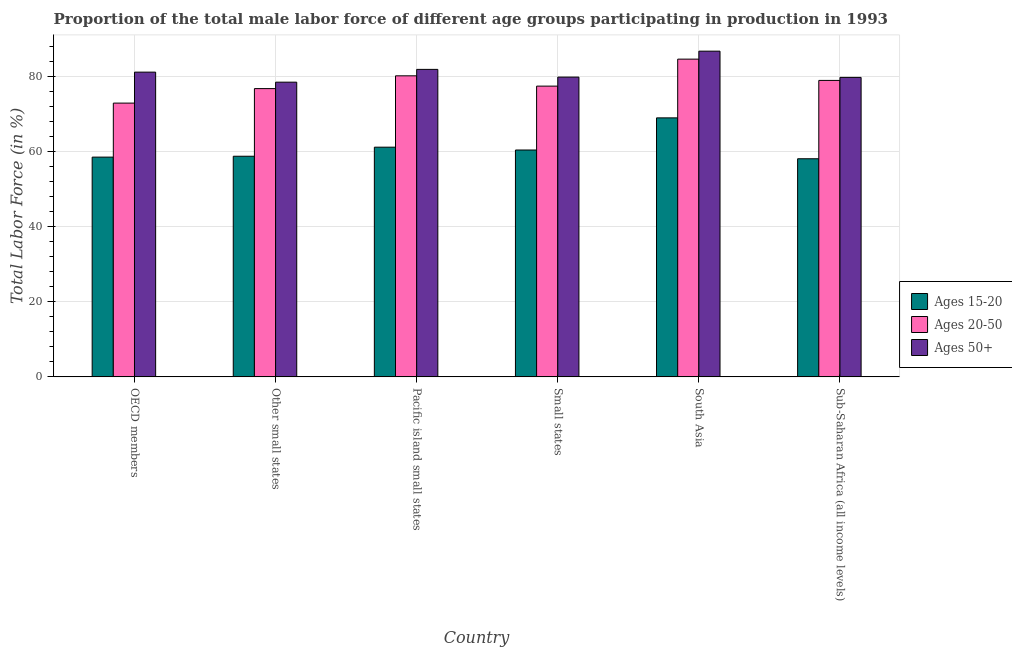How many different coloured bars are there?
Keep it short and to the point. 3. How many groups of bars are there?
Make the answer very short. 6. What is the label of the 2nd group of bars from the left?
Your answer should be very brief. Other small states. In how many cases, is the number of bars for a given country not equal to the number of legend labels?
Provide a short and direct response. 0. What is the percentage of male labor force within the age group 20-50 in Pacific island small states?
Offer a very short reply. 80.16. Across all countries, what is the maximum percentage of male labor force within the age group 15-20?
Make the answer very short. 68.96. Across all countries, what is the minimum percentage of male labor force above age 50?
Ensure brevity in your answer.  78.47. In which country was the percentage of male labor force within the age group 20-50 minimum?
Give a very brief answer. OECD members. What is the total percentage of male labor force above age 50 in the graph?
Provide a short and direct response. 487.77. What is the difference between the percentage of male labor force within the age group 20-50 in OECD members and that in Sub-Saharan Africa (all income levels)?
Give a very brief answer. -6.04. What is the difference between the percentage of male labor force within the age group 15-20 in South Asia and the percentage of male labor force above age 50 in Other small states?
Your response must be concise. -9.51. What is the average percentage of male labor force within the age group 15-20 per country?
Your response must be concise. 60.98. What is the difference between the percentage of male labor force within the age group 15-20 and percentage of male labor force within the age group 20-50 in Other small states?
Your answer should be very brief. -18.01. What is the ratio of the percentage of male labor force within the age group 20-50 in OECD members to that in Small states?
Make the answer very short. 0.94. What is the difference between the highest and the second highest percentage of male labor force within the age group 15-20?
Give a very brief answer. 7.8. What is the difference between the highest and the lowest percentage of male labor force within the age group 20-50?
Offer a terse response. 11.71. Is the sum of the percentage of male labor force within the age group 20-50 in OECD members and Small states greater than the maximum percentage of male labor force above age 50 across all countries?
Offer a very short reply. Yes. What does the 2nd bar from the left in OECD members represents?
Keep it short and to the point. Ages 20-50. What does the 3rd bar from the right in South Asia represents?
Make the answer very short. Ages 15-20. Is it the case that in every country, the sum of the percentage of male labor force within the age group 15-20 and percentage of male labor force within the age group 20-50 is greater than the percentage of male labor force above age 50?
Offer a very short reply. Yes. Does the graph contain grids?
Provide a succinct answer. Yes. Where does the legend appear in the graph?
Give a very brief answer. Center right. How are the legend labels stacked?
Provide a short and direct response. Vertical. What is the title of the graph?
Offer a very short reply. Proportion of the total male labor force of different age groups participating in production in 1993. What is the label or title of the X-axis?
Give a very brief answer. Country. What is the label or title of the Y-axis?
Offer a terse response. Total Labor Force (in %). What is the Total Labor Force (in %) in Ages 15-20 in OECD members?
Provide a short and direct response. 58.51. What is the Total Labor Force (in %) in Ages 20-50 in OECD members?
Your response must be concise. 72.9. What is the Total Labor Force (in %) of Ages 50+ in OECD members?
Make the answer very short. 81.14. What is the Total Labor Force (in %) in Ages 15-20 in Other small states?
Offer a very short reply. 58.75. What is the Total Labor Force (in %) in Ages 20-50 in Other small states?
Provide a short and direct response. 76.76. What is the Total Labor Force (in %) in Ages 50+ in Other small states?
Ensure brevity in your answer.  78.47. What is the Total Labor Force (in %) in Ages 15-20 in Pacific island small states?
Your answer should be very brief. 61.16. What is the Total Labor Force (in %) in Ages 20-50 in Pacific island small states?
Provide a succinct answer. 80.16. What is the Total Labor Force (in %) of Ages 50+ in Pacific island small states?
Your answer should be very brief. 81.87. What is the Total Labor Force (in %) of Ages 15-20 in Small states?
Provide a succinct answer. 60.41. What is the Total Labor Force (in %) of Ages 20-50 in Small states?
Keep it short and to the point. 77.42. What is the Total Labor Force (in %) of Ages 50+ in Small states?
Offer a terse response. 79.82. What is the Total Labor Force (in %) in Ages 15-20 in South Asia?
Give a very brief answer. 68.96. What is the Total Labor Force (in %) of Ages 20-50 in South Asia?
Your answer should be compact. 84.6. What is the Total Labor Force (in %) of Ages 50+ in South Asia?
Ensure brevity in your answer.  86.73. What is the Total Labor Force (in %) of Ages 15-20 in Sub-Saharan Africa (all income levels)?
Your response must be concise. 58.08. What is the Total Labor Force (in %) in Ages 20-50 in Sub-Saharan Africa (all income levels)?
Your response must be concise. 78.94. What is the Total Labor Force (in %) of Ages 50+ in Sub-Saharan Africa (all income levels)?
Your answer should be compact. 79.74. Across all countries, what is the maximum Total Labor Force (in %) in Ages 15-20?
Provide a succinct answer. 68.96. Across all countries, what is the maximum Total Labor Force (in %) of Ages 20-50?
Your answer should be very brief. 84.6. Across all countries, what is the maximum Total Labor Force (in %) of Ages 50+?
Your answer should be very brief. 86.73. Across all countries, what is the minimum Total Labor Force (in %) of Ages 15-20?
Provide a short and direct response. 58.08. Across all countries, what is the minimum Total Labor Force (in %) in Ages 20-50?
Your answer should be very brief. 72.9. Across all countries, what is the minimum Total Labor Force (in %) in Ages 50+?
Make the answer very short. 78.47. What is the total Total Labor Force (in %) of Ages 15-20 in the graph?
Give a very brief answer. 365.87. What is the total Total Labor Force (in %) of Ages 20-50 in the graph?
Provide a succinct answer. 470.78. What is the total Total Labor Force (in %) in Ages 50+ in the graph?
Provide a succinct answer. 487.77. What is the difference between the Total Labor Force (in %) in Ages 15-20 in OECD members and that in Other small states?
Provide a short and direct response. -0.23. What is the difference between the Total Labor Force (in %) in Ages 20-50 in OECD members and that in Other small states?
Your response must be concise. -3.86. What is the difference between the Total Labor Force (in %) in Ages 50+ in OECD members and that in Other small states?
Provide a short and direct response. 2.67. What is the difference between the Total Labor Force (in %) of Ages 15-20 in OECD members and that in Pacific island small states?
Ensure brevity in your answer.  -2.65. What is the difference between the Total Labor Force (in %) in Ages 20-50 in OECD members and that in Pacific island small states?
Provide a short and direct response. -7.26. What is the difference between the Total Labor Force (in %) of Ages 50+ in OECD members and that in Pacific island small states?
Offer a terse response. -0.73. What is the difference between the Total Labor Force (in %) in Ages 15-20 in OECD members and that in Small states?
Your answer should be compact. -1.9. What is the difference between the Total Labor Force (in %) of Ages 20-50 in OECD members and that in Small states?
Keep it short and to the point. -4.52. What is the difference between the Total Labor Force (in %) in Ages 50+ in OECD members and that in Small states?
Your answer should be very brief. 1.32. What is the difference between the Total Labor Force (in %) in Ages 15-20 in OECD members and that in South Asia?
Provide a short and direct response. -10.45. What is the difference between the Total Labor Force (in %) of Ages 20-50 in OECD members and that in South Asia?
Offer a terse response. -11.71. What is the difference between the Total Labor Force (in %) in Ages 50+ in OECD members and that in South Asia?
Give a very brief answer. -5.59. What is the difference between the Total Labor Force (in %) of Ages 15-20 in OECD members and that in Sub-Saharan Africa (all income levels)?
Keep it short and to the point. 0.44. What is the difference between the Total Labor Force (in %) in Ages 20-50 in OECD members and that in Sub-Saharan Africa (all income levels)?
Give a very brief answer. -6.04. What is the difference between the Total Labor Force (in %) of Ages 50+ in OECD members and that in Sub-Saharan Africa (all income levels)?
Your answer should be compact. 1.4. What is the difference between the Total Labor Force (in %) of Ages 15-20 in Other small states and that in Pacific island small states?
Offer a terse response. -2.42. What is the difference between the Total Labor Force (in %) in Ages 20-50 in Other small states and that in Pacific island small states?
Ensure brevity in your answer.  -3.4. What is the difference between the Total Labor Force (in %) in Ages 50+ in Other small states and that in Pacific island small states?
Your response must be concise. -3.4. What is the difference between the Total Labor Force (in %) in Ages 15-20 in Other small states and that in Small states?
Keep it short and to the point. -1.66. What is the difference between the Total Labor Force (in %) in Ages 20-50 in Other small states and that in Small states?
Make the answer very short. -0.66. What is the difference between the Total Labor Force (in %) of Ages 50+ in Other small states and that in Small states?
Provide a succinct answer. -1.35. What is the difference between the Total Labor Force (in %) of Ages 15-20 in Other small states and that in South Asia?
Make the answer very short. -10.22. What is the difference between the Total Labor Force (in %) in Ages 20-50 in Other small states and that in South Asia?
Give a very brief answer. -7.84. What is the difference between the Total Labor Force (in %) of Ages 50+ in Other small states and that in South Asia?
Your answer should be very brief. -8.26. What is the difference between the Total Labor Force (in %) of Ages 15-20 in Other small states and that in Sub-Saharan Africa (all income levels)?
Offer a very short reply. 0.67. What is the difference between the Total Labor Force (in %) of Ages 20-50 in Other small states and that in Sub-Saharan Africa (all income levels)?
Provide a succinct answer. -2.18. What is the difference between the Total Labor Force (in %) of Ages 50+ in Other small states and that in Sub-Saharan Africa (all income levels)?
Offer a very short reply. -1.27. What is the difference between the Total Labor Force (in %) of Ages 15-20 in Pacific island small states and that in Small states?
Provide a succinct answer. 0.75. What is the difference between the Total Labor Force (in %) of Ages 20-50 in Pacific island small states and that in Small states?
Ensure brevity in your answer.  2.74. What is the difference between the Total Labor Force (in %) of Ages 50+ in Pacific island small states and that in Small states?
Ensure brevity in your answer.  2.05. What is the difference between the Total Labor Force (in %) of Ages 15-20 in Pacific island small states and that in South Asia?
Your answer should be very brief. -7.8. What is the difference between the Total Labor Force (in %) of Ages 20-50 in Pacific island small states and that in South Asia?
Your answer should be very brief. -4.44. What is the difference between the Total Labor Force (in %) in Ages 50+ in Pacific island small states and that in South Asia?
Keep it short and to the point. -4.85. What is the difference between the Total Labor Force (in %) in Ages 15-20 in Pacific island small states and that in Sub-Saharan Africa (all income levels)?
Offer a terse response. 3.08. What is the difference between the Total Labor Force (in %) of Ages 20-50 in Pacific island small states and that in Sub-Saharan Africa (all income levels)?
Your answer should be compact. 1.22. What is the difference between the Total Labor Force (in %) in Ages 50+ in Pacific island small states and that in Sub-Saharan Africa (all income levels)?
Your response must be concise. 2.13. What is the difference between the Total Labor Force (in %) in Ages 15-20 in Small states and that in South Asia?
Offer a very short reply. -8.55. What is the difference between the Total Labor Force (in %) of Ages 20-50 in Small states and that in South Asia?
Your response must be concise. -7.19. What is the difference between the Total Labor Force (in %) in Ages 50+ in Small states and that in South Asia?
Your response must be concise. -6.91. What is the difference between the Total Labor Force (in %) of Ages 15-20 in Small states and that in Sub-Saharan Africa (all income levels)?
Your response must be concise. 2.33. What is the difference between the Total Labor Force (in %) of Ages 20-50 in Small states and that in Sub-Saharan Africa (all income levels)?
Provide a short and direct response. -1.52. What is the difference between the Total Labor Force (in %) of Ages 50+ in Small states and that in Sub-Saharan Africa (all income levels)?
Offer a terse response. 0.08. What is the difference between the Total Labor Force (in %) in Ages 15-20 in South Asia and that in Sub-Saharan Africa (all income levels)?
Ensure brevity in your answer.  10.89. What is the difference between the Total Labor Force (in %) of Ages 20-50 in South Asia and that in Sub-Saharan Africa (all income levels)?
Offer a terse response. 5.67. What is the difference between the Total Labor Force (in %) of Ages 50+ in South Asia and that in Sub-Saharan Africa (all income levels)?
Your answer should be very brief. 6.99. What is the difference between the Total Labor Force (in %) in Ages 15-20 in OECD members and the Total Labor Force (in %) in Ages 20-50 in Other small states?
Ensure brevity in your answer.  -18.25. What is the difference between the Total Labor Force (in %) of Ages 15-20 in OECD members and the Total Labor Force (in %) of Ages 50+ in Other small states?
Your answer should be compact. -19.96. What is the difference between the Total Labor Force (in %) of Ages 20-50 in OECD members and the Total Labor Force (in %) of Ages 50+ in Other small states?
Provide a short and direct response. -5.57. What is the difference between the Total Labor Force (in %) in Ages 15-20 in OECD members and the Total Labor Force (in %) in Ages 20-50 in Pacific island small states?
Ensure brevity in your answer.  -21.65. What is the difference between the Total Labor Force (in %) of Ages 15-20 in OECD members and the Total Labor Force (in %) of Ages 50+ in Pacific island small states?
Provide a short and direct response. -23.36. What is the difference between the Total Labor Force (in %) in Ages 20-50 in OECD members and the Total Labor Force (in %) in Ages 50+ in Pacific island small states?
Keep it short and to the point. -8.98. What is the difference between the Total Labor Force (in %) in Ages 15-20 in OECD members and the Total Labor Force (in %) in Ages 20-50 in Small states?
Ensure brevity in your answer.  -18.9. What is the difference between the Total Labor Force (in %) of Ages 15-20 in OECD members and the Total Labor Force (in %) of Ages 50+ in Small states?
Make the answer very short. -21.31. What is the difference between the Total Labor Force (in %) of Ages 20-50 in OECD members and the Total Labor Force (in %) of Ages 50+ in Small states?
Your answer should be compact. -6.92. What is the difference between the Total Labor Force (in %) in Ages 15-20 in OECD members and the Total Labor Force (in %) in Ages 20-50 in South Asia?
Offer a very short reply. -26.09. What is the difference between the Total Labor Force (in %) of Ages 15-20 in OECD members and the Total Labor Force (in %) of Ages 50+ in South Asia?
Keep it short and to the point. -28.21. What is the difference between the Total Labor Force (in %) of Ages 20-50 in OECD members and the Total Labor Force (in %) of Ages 50+ in South Asia?
Your answer should be compact. -13.83. What is the difference between the Total Labor Force (in %) in Ages 15-20 in OECD members and the Total Labor Force (in %) in Ages 20-50 in Sub-Saharan Africa (all income levels)?
Offer a very short reply. -20.42. What is the difference between the Total Labor Force (in %) of Ages 15-20 in OECD members and the Total Labor Force (in %) of Ages 50+ in Sub-Saharan Africa (all income levels)?
Offer a very short reply. -21.23. What is the difference between the Total Labor Force (in %) in Ages 20-50 in OECD members and the Total Labor Force (in %) in Ages 50+ in Sub-Saharan Africa (all income levels)?
Provide a succinct answer. -6.84. What is the difference between the Total Labor Force (in %) of Ages 15-20 in Other small states and the Total Labor Force (in %) of Ages 20-50 in Pacific island small states?
Provide a succinct answer. -21.42. What is the difference between the Total Labor Force (in %) in Ages 15-20 in Other small states and the Total Labor Force (in %) in Ages 50+ in Pacific island small states?
Keep it short and to the point. -23.13. What is the difference between the Total Labor Force (in %) of Ages 20-50 in Other small states and the Total Labor Force (in %) of Ages 50+ in Pacific island small states?
Provide a succinct answer. -5.11. What is the difference between the Total Labor Force (in %) of Ages 15-20 in Other small states and the Total Labor Force (in %) of Ages 20-50 in Small states?
Offer a very short reply. -18.67. What is the difference between the Total Labor Force (in %) in Ages 15-20 in Other small states and the Total Labor Force (in %) in Ages 50+ in Small states?
Your answer should be very brief. -21.07. What is the difference between the Total Labor Force (in %) of Ages 20-50 in Other small states and the Total Labor Force (in %) of Ages 50+ in Small states?
Give a very brief answer. -3.06. What is the difference between the Total Labor Force (in %) of Ages 15-20 in Other small states and the Total Labor Force (in %) of Ages 20-50 in South Asia?
Make the answer very short. -25.86. What is the difference between the Total Labor Force (in %) of Ages 15-20 in Other small states and the Total Labor Force (in %) of Ages 50+ in South Asia?
Ensure brevity in your answer.  -27.98. What is the difference between the Total Labor Force (in %) of Ages 20-50 in Other small states and the Total Labor Force (in %) of Ages 50+ in South Asia?
Offer a very short reply. -9.97. What is the difference between the Total Labor Force (in %) of Ages 15-20 in Other small states and the Total Labor Force (in %) of Ages 20-50 in Sub-Saharan Africa (all income levels)?
Provide a succinct answer. -20.19. What is the difference between the Total Labor Force (in %) in Ages 15-20 in Other small states and the Total Labor Force (in %) in Ages 50+ in Sub-Saharan Africa (all income levels)?
Provide a short and direct response. -21. What is the difference between the Total Labor Force (in %) in Ages 20-50 in Other small states and the Total Labor Force (in %) in Ages 50+ in Sub-Saharan Africa (all income levels)?
Provide a short and direct response. -2.98. What is the difference between the Total Labor Force (in %) of Ages 15-20 in Pacific island small states and the Total Labor Force (in %) of Ages 20-50 in Small states?
Your answer should be compact. -16.26. What is the difference between the Total Labor Force (in %) of Ages 15-20 in Pacific island small states and the Total Labor Force (in %) of Ages 50+ in Small states?
Your answer should be compact. -18.66. What is the difference between the Total Labor Force (in %) in Ages 20-50 in Pacific island small states and the Total Labor Force (in %) in Ages 50+ in Small states?
Your answer should be very brief. 0.34. What is the difference between the Total Labor Force (in %) in Ages 15-20 in Pacific island small states and the Total Labor Force (in %) in Ages 20-50 in South Asia?
Keep it short and to the point. -23.44. What is the difference between the Total Labor Force (in %) in Ages 15-20 in Pacific island small states and the Total Labor Force (in %) in Ages 50+ in South Asia?
Provide a short and direct response. -25.57. What is the difference between the Total Labor Force (in %) of Ages 20-50 in Pacific island small states and the Total Labor Force (in %) of Ages 50+ in South Asia?
Keep it short and to the point. -6.57. What is the difference between the Total Labor Force (in %) of Ages 15-20 in Pacific island small states and the Total Labor Force (in %) of Ages 20-50 in Sub-Saharan Africa (all income levels)?
Give a very brief answer. -17.78. What is the difference between the Total Labor Force (in %) in Ages 15-20 in Pacific island small states and the Total Labor Force (in %) in Ages 50+ in Sub-Saharan Africa (all income levels)?
Ensure brevity in your answer.  -18.58. What is the difference between the Total Labor Force (in %) of Ages 20-50 in Pacific island small states and the Total Labor Force (in %) of Ages 50+ in Sub-Saharan Africa (all income levels)?
Provide a succinct answer. 0.42. What is the difference between the Total Labor Force (in %) in Ages 15-20 in Small states and the Total Labor Force (in %) in Ages 20-50 in South Asia?
Offer a very short reply. -24.2. What is the difference between the Total Labor Force (in %) in Ages 15-20 in Small states and the Total Labor Force (in %) in Ages 50+ in South Asia?
Your response must be concise. -26.32. What is the difference between the Total Labor Force (in %) in Ages 20-50 in Small states and the Total Labor Force (in %) in Ages 50+ in South Asia?
Keep it short and to the point. -9.31. What is the difference between the Total Labor Force (in %) of Ages 15-20 in Small states and the Total Labor Force (in %) of Ages 20-50 in Sub-Saharan Africa (all income levels)?
Keep it short and to the point. -18.53. What is the difference between the Total Labor Force (in %) of Ages 15-20 in Small states and the Total Labor Force (in %) of Ages 50+ in Sub-Saharan Africa (all income levels)?
Ensure brevity in your answer.  -19.33. What is the difference between the Total Labor Force (in %) in Ages 20-50 in Small states and the Total Labor Force (in %) in Ages 50+ in Sub-Saharan Africa (all income levels)?
Provide a succinct answer. -2.32. What is the difference between the Total Labor Force (in %) of Ages 15-20 in South Asia and the Total Labor Force (in %) of Ages 20-50 in Sub-Saharan Africa (all income levels)?
Keep it short and to the point. -9.97. What is the difference between the Total Labor Force (in %) of Ages 15-20 in South Asia and the Total Labor Force (in %) of Ages 50+ in Sub-Saharan Africa (all income levels)?
Your response must be concise. -10.78. What is the difference between the Total Labor Force (in %) of Ages 20-50 in South Asia and the Total Labor Force (in %) of Ages 50+ in Sub-Saharan Africa (all income levels)?
Ensure brevity in your answer.  4.86. What is the average Total Labor Force (in %) in Ages 15-20 per country?
Your answer should be very brief. 60.98. What is the average Total Labor Force (in %) in Ages 20-50 per country?
Ensure brevity in your answer.  78.46. What is the average Total Labor Force (in %) of Ages 50+ per country?
Ensure brevity in your answer.  81.3. What is the difference between the Total Labor Force (in %) in Ages 15-20 and Total Labor Force (in %) in Ages 20-50 in OECD members?
Give a very brief answer. -14.38. What is the difference between the Total Labor Force (in %) in Ages 15-20 and Total Labor Force (in %) in Ages 50+ in OECD members?
Give a very brief answer. -22.63. What is the difference between the Total Labor Force (in %) of Ages 20-50 and Total Labor Force (in %) of Ages 50+ in OECD members?
Give a very brief answer. -8.24. What is the difference between the Total Labor Force (in %) of Ages 15-20 and Total Labor Force (in %) of Ages 20-50 in Other small states?
Your response must be concise. -18.01. What is the difference between the Total Labor Force (in %) of Ages 15-20 and Total Labor Force (in %) of Ages 50+ in Other small states?
Your answer should be compact. -19.72. What is the difference between the Total Labor Force (in %) in Ages 20-50 and Total Labor Force (in %) in Ages 50+ in Other small states?
Your response must be concise. -1.71. What is the difference between the Total Labor Force (in %) in Ages 15-20 and Total Labor Force (in %) in Ages 20-50 in Pacific island small states?
Provide a succinct answer. -19. What is the difference between the Total Labor Force (in %) in Ages 15-20 and Total Labor Force (in %) in Ages 50+ in Pacific island small states?
Make the answer very short. -20.71. What is the difference between the Total Labor Force (in %) of Ages 20-50 and Total Labor Force (in %) of Ages 50+ in Pacific island small states?
Your response must be concise. -1.71. What is the difference between the Total Labor Force (in %) in Ages 15-20 and Total Labor Force (in %) in Ages 20-50 in Small states?
Offer a terse response. -17.01. What is the difference between the Total Labor Force (in %) in Ages 15-20 and Total Labor Force (in %) in Ages 50+ in Small states?
Your answer should be compact. -19.41. What is the difference between the Total Labor Force (in %) of Ages 20-50 and Total Labor Force (in %) of Ages 50+ in Small states?
Provide a short and direct response. -2.4. What is the difference between the Total Labor Force (in %) in Ages 15-20 and Total Labor Force (in %) in Ages 20-50 in South Asia?
Your response must be concise. -15.64. What is the difference between the Total Labor Force (in %) of Ages 15-20 and Total Labor Force (in %) of Ages 50+ in South Asia?
Give a very brief answer. -17.76. What is the difference between the Total Labor Force (in %) of Ages 20-50 and Total Labor Force (in %) of Ages 50+ in South Asia?
Your answer should be compact. -2.12. What is the difference between the Total Labor Force (in %) of Ages 15-20 and Total Labor Force (in %) of Ages 20-50 in Sub-Saharan Africa (all income levels)?
Make the answer very short. -20.86. What is the difference between the Total Labor Force (in %) of Ages 15-20 and Total Labor Force (in %) of Ages 50+ in Sub-Saharan Africa (all income levels)?
Provide a succinct answer. -21.66. What is the difference between the Total Labor Force (in %) in Ages 20-50 and Total Labor Force (in %) in Ages 50+ in Sub-Saharan Africa (all income levels)?
Give a very brief answer. -0.8. What is the ratio of the Total Labor Force (in %) of Ages 20-50 in OECD members to that in Other small states?
Provide a succinct answer. 0.95. What is the ratio of the Total Labor Force (in %) of Ages 50+ in OECD members to that in Other small states?
Make the answer very short. 1.03. What is the ratio of the Total Labor Force (in %) of Ages 15-20 in OECD members to that in Pacific island small states?
Make the answer very short. 0.96. What is the ratio of the Total Labor Force (in %) in Ages 20-50 in OECD members to that in Pacific island small states?
Ensure brevity in your answer.  0.91. What is the ratio of the Total Labor Force (in %) in Ages 50+ in OECD members to that in Pacific island small states?
Keep it short and to the point. 0.99. What is the ratio of the Total Labor Force (in %) of Ages 15-20 in OECD members to that in Small states?
Keep it short and to the point. 0.97. What is the ratio of the Total Labor Force (in %) of Ages 20-50 in OECD members to that in Small states?
Offer a very short reply. 0.94. What is the ratio of the Total Labor Force (in %) of Ages 50+ in OECD members to that in Small states?
Provide a short and direct response. 1.02. What is the ratio of the Total Labor Force (in %) in Ages 15-20 in OECD members to that in South Asia?
Keep it short and to the point. 0.85. What is the ratio of the Total Labor Force (in %) in Ages 20-50 in OECD members to that in South Asia?
Make the answer very short. 0.86. What is the ratio of the Total Labor Force (in %) in Ages 50+ in OECD members to that in South Asia?
Provide a short and direct response. 0.94. What is the ratio of the Total Labor Force (in %) of Ages 15-20 in OECD members to that in Sub-Saharan Africa (all income levels)?
Your answer should be very brief. 1.01. What is the ratio of the Total Labor Force (in %) of Ages 20-50 in OECD members to that in Sub-Saharan Africa (all income levels)?
Your response must be concise. 0.92. What is the ratio of the Total Labor Force (in %) of Ages 50+ in OECD members to that in Sub-Saharan Africa (all income levels)?
Ensure brevity in your answer.  1.02. What is the ratio of the Total Labor Force (in %) in Ages 15-20 in Other small states to that in Pacific island small states?
Your answer should be compact. 0.96. What is the ratio of the Total Labor Force (in %) in Ages 20-50 in Other small states to that in Pacific island small states?
Provide a short and direct response. 0.96. What is the ratio of the Total Labor Force (in %) of Ages 50+ in Other small states to that in Pacific island small states?
Ensure brevity in your answer.  0.96. What is the ratio of the Total Labor Force (in %) of Ages 15-20 in Other small states to that in Small states?
Offer a very short reply. 0.97. What is the ratio of the Total Labor Force (in %) in Ages 20-50 in Other small states to that in Small states?
Keep it short and to the point. 0.99. What is the ratio of the Total Labor Force (in %) of Ages 50+ in Other small states to that in Small states?
Ensure brevity in your answer.  0.98. What is the ratio of the Total Labor Force (in %) in Ages 15-20 in Other small states to that in South Asia?
Keep it short and to the point. 0.85. What is the ratio of the Total Labor Force (in %) in Ages 20-50 in Other small states to that in South Asia?
Offer a very short reply. 0.91. What is the ratio of the Total Labor Force (in %) in Ages 50+ in Other small states to that in South Asia?
Ensure brevity in your answer.  0.9. What is the ratio of the Total Labor Force (in %) of Ages 15-20 in Other small states to that in Sub-Saharan Africa (all income levels)?
Provide a short and direct response. 1.01. What is the ratio of the Total Labor Force (in %) in Ages 20-50 in Other small states to that in Sub-Saharan Africa (all income levels)?
Your answer should be compact. 0.97. What is the ratio of the Total Labor Force (in %) in Ages 50+ in Other small states to that in Sub-Saharan Africa (all income levels)?
Your answer should be compact. 0.98. What is the ratio of the Total Labor Force (in %) of Ages 15-20 in Pacific island small states to that in Small states?
Ensure brevity in your answer.  1.01. What is the ratio of the Total Labor Force (in %) in Ages 20-50 in Pacific island small states to that in Small states?
Your answer should be compact. 1.04. What is the ratio of the Total Labor Force (in %) of Ages 50+ in Pacific island small states to that in Small states?
Keep it short and to the point. 1.03. What is the ratio of the Total Labor Force (in %) of Ages 15-20 in Pacific island small states to that in South Asia?
Ensure brevity in your answer.  0.89. What is the ratio of the Total Labor Force (in %) in Ages 20-50 in Pacific island small states to that in South Asia?
Your answer should be very brief. 0.95. What is the ratio of the Total Labor Force (in %) of Ages 50+ in Pacific island small states to that in South Asia?
Your answer should be compact. 0.94. What is the ratio of the Total Labor Force (in %) of Ages 15-20 in Pacific island small states to that in Sub-Saharan Africa (all income levels)?
Offer a very short reply. 1.05. What is the ratio of the Total Labor Force (in %) in Ages 20-50 in Pacific island small states to that in Sub-Saharan Africa (all income levels)?
Your answer should be compact. 1.02. What is the ratio of the Total Labor Force (in %) in Ages 50+ in Pacific island small states to that in Sub-Saharan Africa (all income levels)?
Provide a short and direct response. 1.03. What is the ratio of the Total Labor Force (in %) in Ages 15-20 in Small states to that in South Asia?
Your answer should be compact. 0.88. What is the ratio of the Total Labor Force (in %) in Ages 20-50 in Small states to that in South Asia?
Offer a terse response. 0.92. What is the ratio of the Total Labor Force (in %) of Ages 50+ in Small states to that in South Asia?
Your response must be concise. 0.92. What is the ratio of the Total Labor Force (in %) of Ages 15-20 in Small states to that in Sub-Saharan Africa (all income levels)?
Ensure brevity in your answer.  1.04. What is the ratio of the Total Labor Force (in %) of Ages 20-50 in Small states to that in Sub-Saharan Africa (all income levels)?
Your answer should be very brief. 0.98. What is the ratio of the Total Labor Force (in %) in Ages 15-20 in South Asia to that in Sub-Saharan Africa (all income levels)?
Ensure brevity in your answer.  1.19. What is the ratio of the Total Labor Force (in %) of Ages 20-50 in South Asia to that in Sub-Saharan Africa (all income levels)?
Offer a terse response. 1.07. What is the ratio of the Total Labor Force (in %) of Ages 50+ in South Asia to that in Sub-Saharan Africa (all income levels)?
Make the answer very short. 1.09. What is the difference between the highest and the second highest Total Labor Force (in %) in Ages 15-20?
Your response must be concise. 7.8. What is the difference between the highest and the second highest Total Labor Force (in %) of Ages 20-50?
Make the answer very short. 4.44. What is the difference between the highest and the second highest Total Labor Force (in %) of Ages 50+?
Ensure brevity in your answer.  4.85. What is the difference between the highest and the lowest Total Labor Force (in %) in Ages 15-20?
Offer a very short reply. 10.89. What is the difference between the highest and the lowest Total Labor Force (in %) of Ages 20-50?
Your response must be concise. 11.71. What is the difference between the highest and the lowest Total Labor Force (in %) in Ages 50+?
Give a very brief answer. 8.26. 